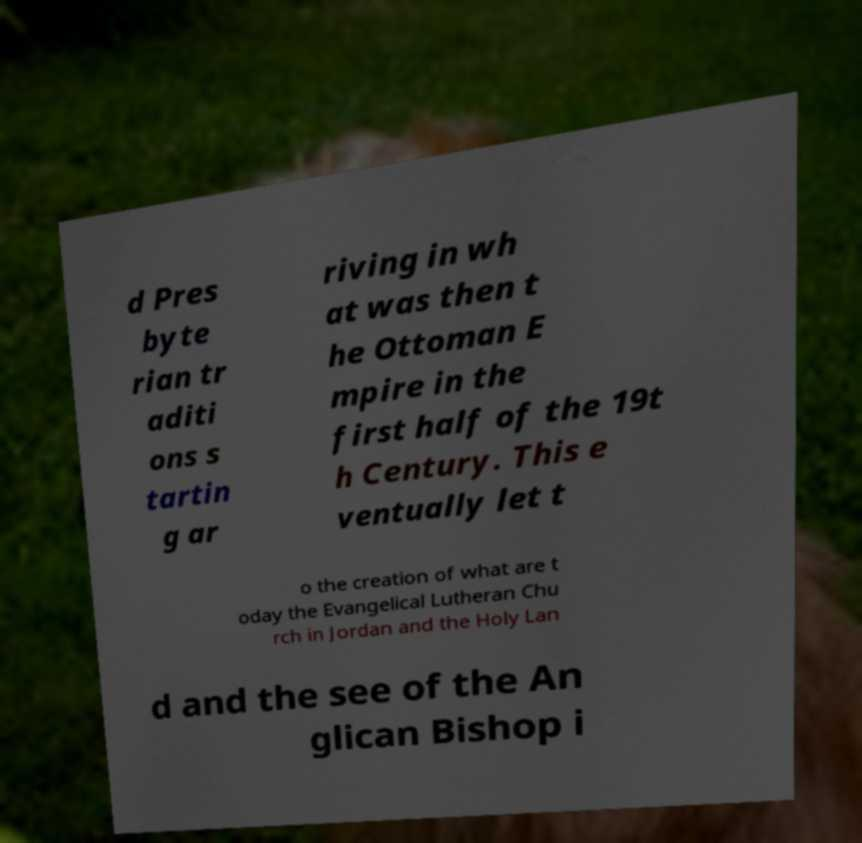Can you read and provide the text displayed in the image?This photo seems to have some interesting text. Can you extract and type it out for me? d Pres byte rian tr aditi ons s tartin g ar riving in wh at was then t he Ottoman E mpire in the first half of the 19t h Century. This e ventually let t o the creation of what are t oday the Evangelical Lutheran Chu rch in Jordan and the Holy Lan d and the see of the An glican Bishop i 